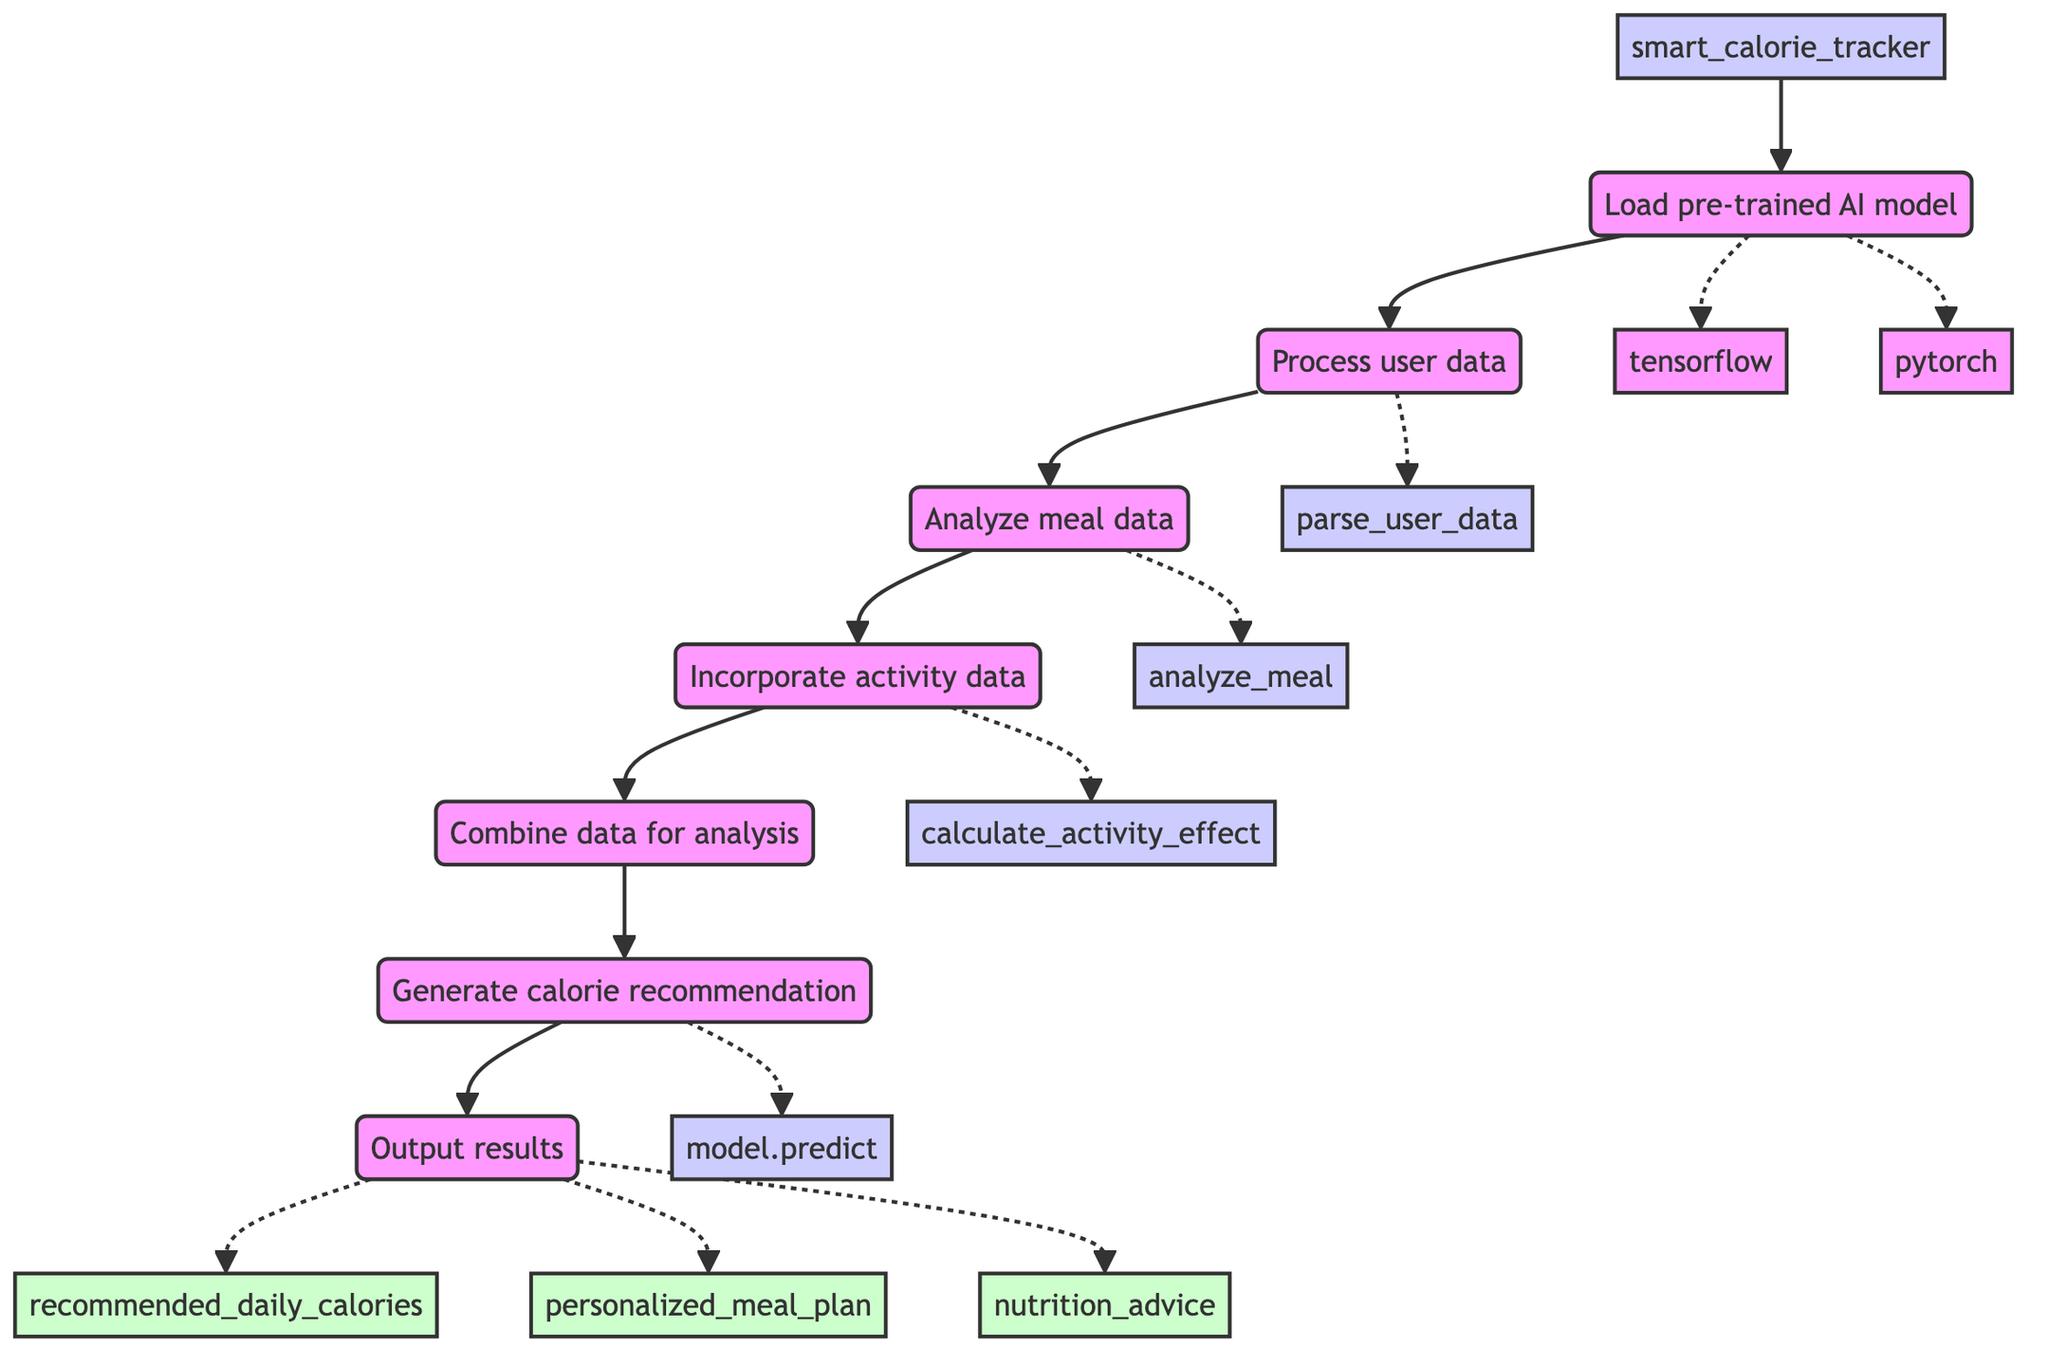What is the first step in the smart calorie tracker function? The first step listed in the flowchart is "Load pre-trained AI model." This step is directly connected from the function node and indicates the initial action taken to begin the calorie tracking process.
Answer: Load pre-trained AI model How many libraries are involved in loading the pre-trained AI model? There are two libraries mentioned in the flowchart for loading the AI model: TensorFlow and PyTorch. This information is derived from the branches that lead from the "Load pre-trained AI model" step.
Answer: Two Which function is used to process user data? The flowchart specifies that "parse_user_data(user_data)" is the function used to process user data. This function is connected directly beneath the "Process user data" step in the diagram.
Answer: parse_user_data What components are analyzed in the meal data step? The meal data analysis step includes components such as calories, macronutrients, micronutrients, and meal type. These components are clearly listed under the "Analyze meal data" step in the flowchart.
Answer: calories, macronutrients, micronutrients, meal type What is the output of the smart calorie tracker function? The output includes "recommended_daily_calories," "personalized_meal_plan," and "nutrition_advice." These outputs are found beneath the "Output results" step, indicating what the function returns to the user.
Answer: recommended_daily_calories, personalized_meal_plan, nutrition_advice Which step comes after incorporating activity data? The step that follows "Incorporate activity data" is "Combine data for analysis." This sequence is established by the direct connection that moves from one step to the next within the flowchart.
Answer: Combine data for analysis How is the calorie recommendation generated? The calorie recommendation is generated by calling the function "model.predict(processed_data)." This is indicated in the flowchart as the process that comes after combining the data for analysis.
Answer: model.predict(processed_data) What types of data are processed together for analysis? The data types processed together include user data, meal data, and activity data. This is summarized in the step "Combine data for analysis," where the purpose is to merge these three data inputs.
Answer: user data, meal data, activity data How many output parameters come from the smart calorie tracker function? There are three output parameters listed: recommended_daily_calories, personalized_meal_plan, and nutrition_advice. This count directly corresponds to the three outputs indicated beneath the "Output results" step.
Answer: Three 